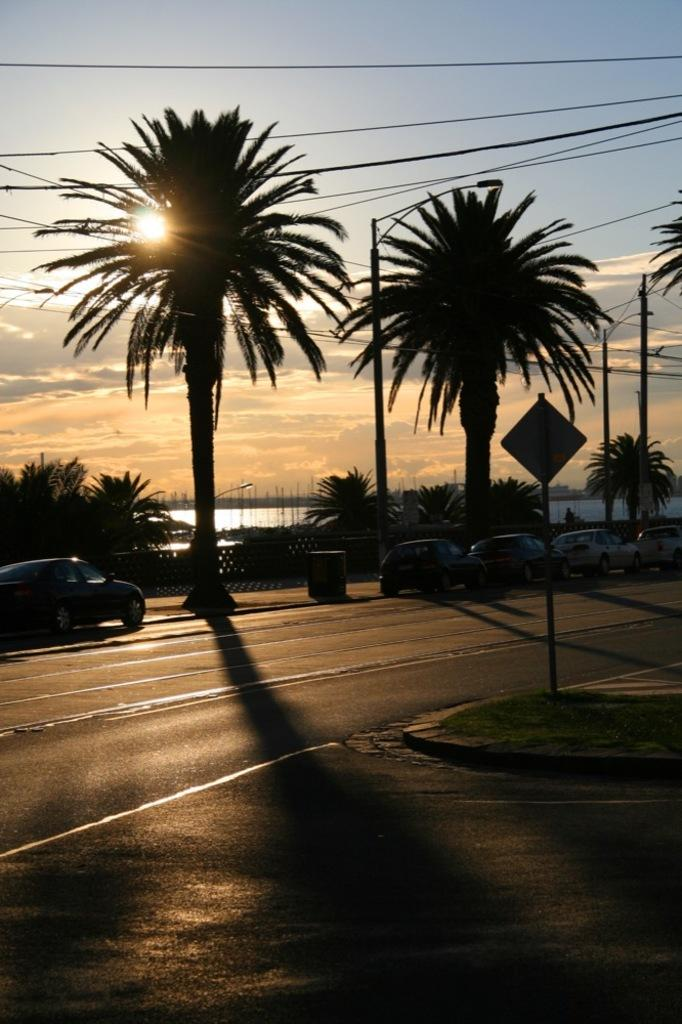What type of vegetation can be seen in the image? There are trees in the image. What is attached to the poles in the image? There is a sign board on a pole in the image. What type of vehicles are on the road in the image? There are cars on the road in the image. What is visible in the image besides the trees and cars? There is water visible in the image. What is the condition of the sky in the image? The sky is cloudy in the image. Can you see any sunlight in the image? Yes, sunlight is visible in the image. How many cherries are hanging from the trees in the image? There are no cherries visible in the image; only trees are present. Can you hear anyone laughing in the image? There is no audible sound in the image, so it is not possible to determine if anyone is laughing. 